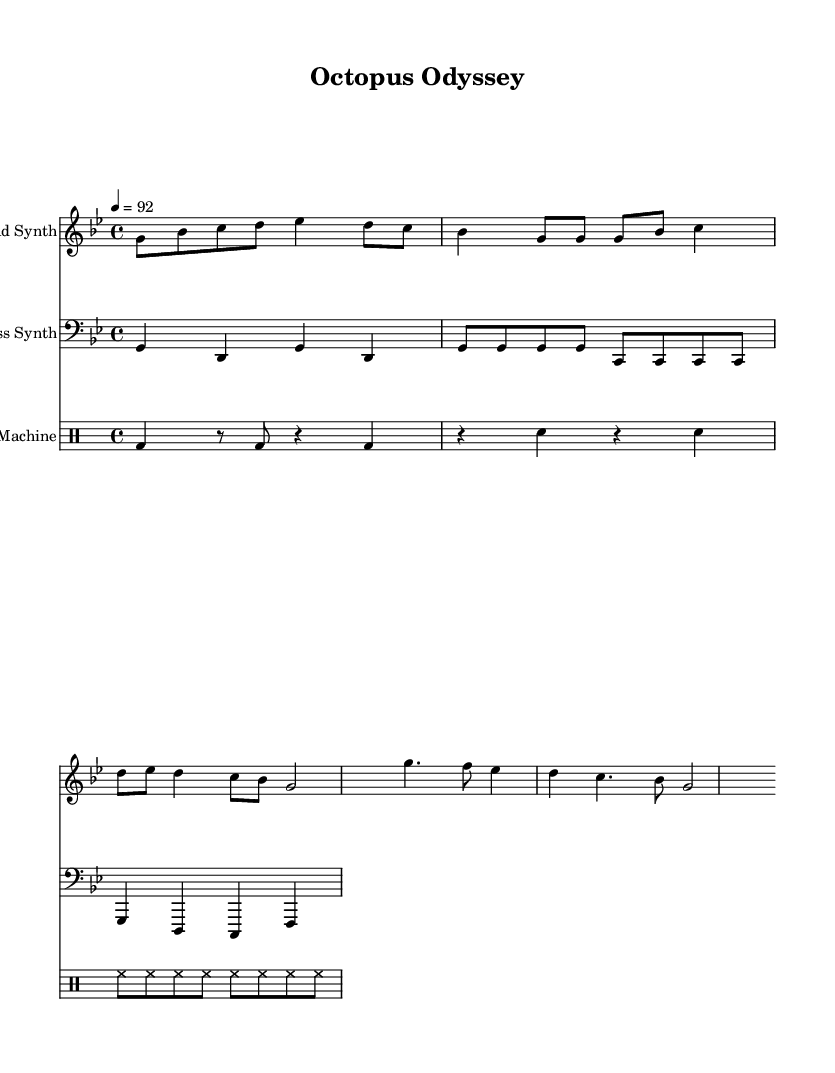What is the key signature of this music? The key signature is G minor, which has two flats (B flat and E flat) in the key signature. You can identify the key signature by looking at the clef and the sharps or flats at the beginning of the staff.
Answer: G minor What is the time signature of the piece? The time signature is 4/4, indicating that there are four beats in a measure and the quarter note receives one beat. This can be observed at the beginning of the sheet music.
Answer: 4/4 What is the tempo marking for this composition? The tempo marking is 4 = 92, which indicates that there are 92 beats per minute with each quarter note representing one beat. This helps to set the pace of the music.
Answer: 92 How many measures are in the verse section? The verse section contains 4 measures, which can be counted in the first half of the score after the introduction. Each group of notes separated by vertical lines represents one measure.
Answer: 4 Which staff has the drums written on it? The drums are written on the Drum Staff, which is labeled specifically for the drum machine part in the score. This staff is distinct from the others designated for lead and bass synths.
Answer: Drum Staff What is the rhythmic pattern of the hi-hat in the drum section? The hi-hat has a consistent eighth note pattern, which can be seen from the repetitive notation of sixteenth notes indicating steady beats. This creates a driving rhythm typical of hip-hop.
Answer: Eighth notes What is the primary musical form of the piece? The primary musical form is Verse-Chorus, where the structure alternates between a verse and a chorus. This is a common form in hip-hop music, focusing on catchy hooks and thematic verses.
Answer: Verse-Chorus 